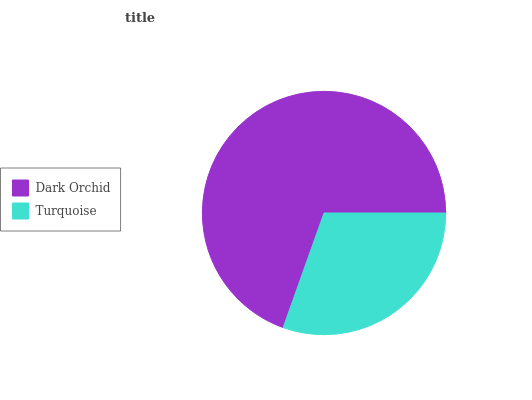Is Turquoise the minimum?
Answer yes or no. Yes. Is Dark Orchid the maximum?
Answer yes or no. Yes. Is Turquoise the maximum?
Answer yes or no. No. Is Dark Orchid greater than Turquoise?
Answer yes or no. Yes. Is Turquoise less than Dark Orchid?
Answer yes or no. Yes. Is Turquoise greater than Dark Orchid?
Answer yes or no. No. Is Dark Orchid less than Turquoise?
Answer yes or no. No. Is Dark Orchid the high median?
Answer yes or no. Yes. Is Turquoise the low median?
Answer yes or no. Yes. Is Turquoise the high median?
Answer yes or no. No. Is Dark Orchid the low median?
Answer yes or no. No. 